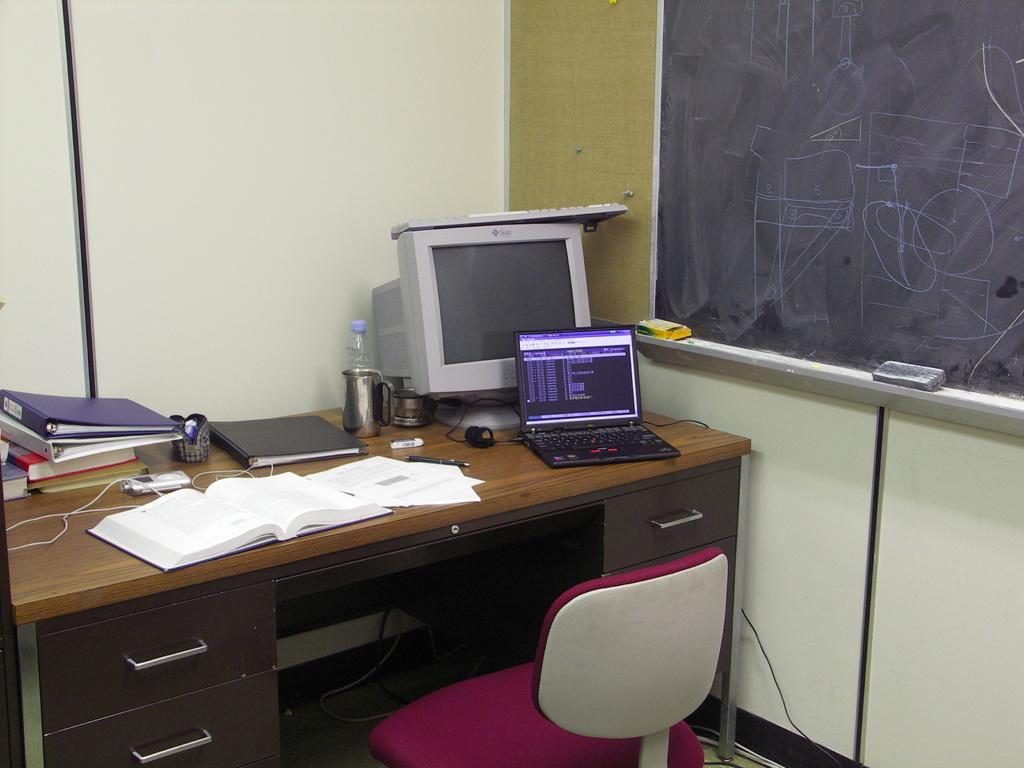What electronic device is visible in the image? There is a laptop in the image. What else can be seen in the image that might be related to technology? There is a system (possibly a computer) in the image. What type of reading material is present in the image? There are books in the image. What is the container for a liquid in the image? There is a flask in the image. What is the transparent container for a beverage in the image? There is a glass in the image. Where are these objects located? The objects are on a table. What piece of furniture is in front of the table? There is a chair in front of the table. What is attached to the wall in the image? There is a board attached to the wall. What type of coal is being used to heat the room in the image? There is no coal present in the image, and the image does not depict a room being heated. 